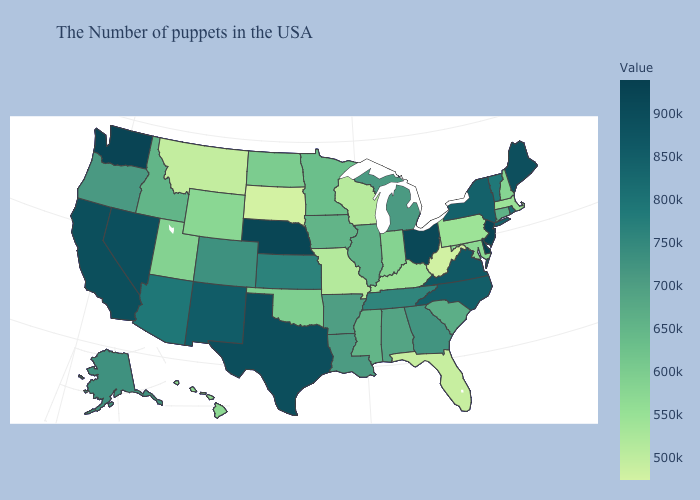Does Mississippi have a higher value than Texas?
Give a very brief answer. No. Among the states that border Washington , does Idaho have the highest value?
Keep it brief. No. Does the map have missing data?
Answer briefly. No. Which states have the highest value in the USA?
Answer briefly. Delaware. Does Iowa have a higher value than Wisconsin?
Short answer required. Yes. Among the states that border Missouri , does Iowa have the highest value?
Answer briefly. No. Does South Dakota have the lowest value in the USA?
Concise answer only. Yes. 